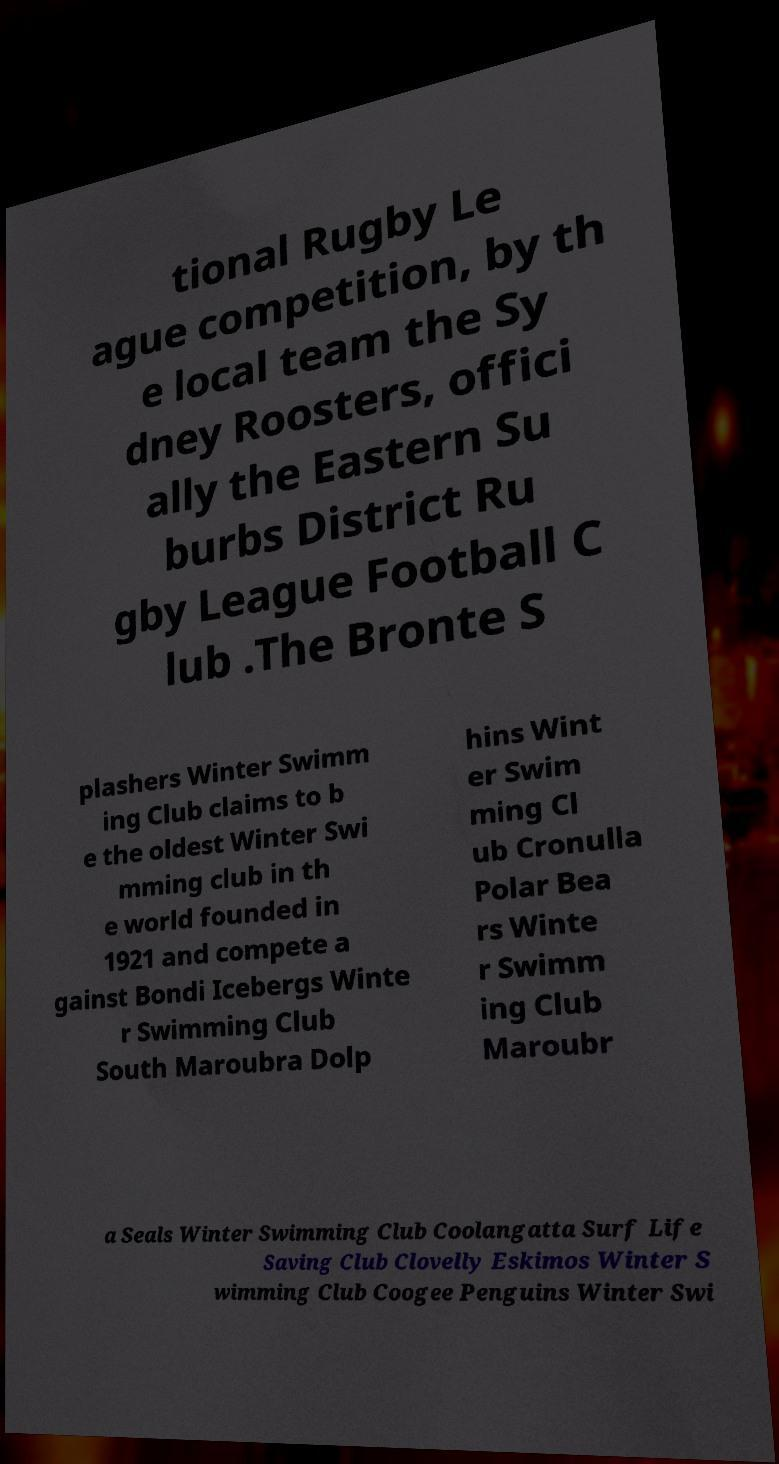Can you accurately transcribe the text from the provided image for me? tional Rugby Le ague competition, by th e local team the Sy dney Roosters, offici ally the Eastern Su burbs District Ru gby League Football C lub .The Bronte S plashers Winter Swimm ing Club claims to b e the oldest Winter Swi mming club in th e world founded in 1921 and compete a gainst Bondi Icebergs Winte r Swimming Club South Maroubra Dolp hins Wint er Swim ming Cl ub Cronulla Polar Bea rs Winte r Swimm ing Club Maroubr a Seals Winter Swimming Club Coolangatta Surf Life Saving Club Clovelly Eskimos Winter S wimming Club Coogee Penguins Winter Swi 